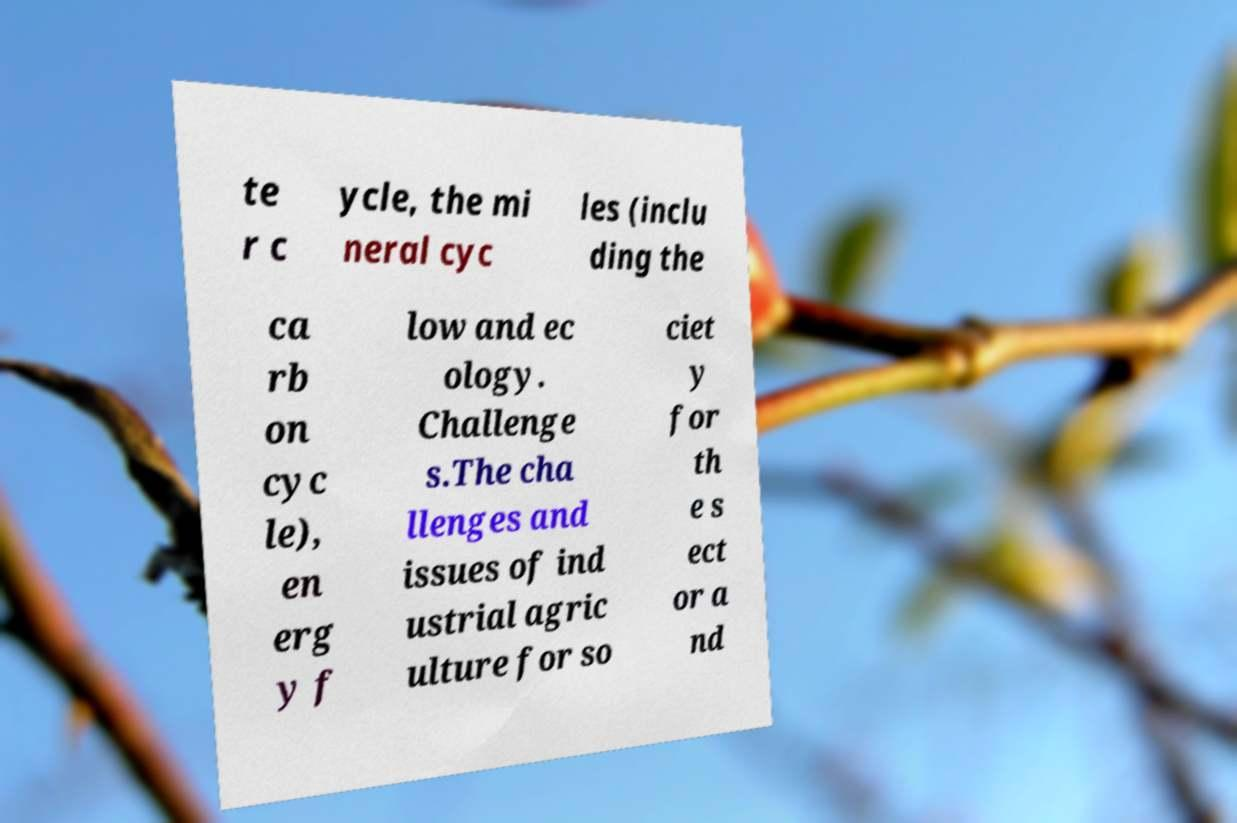What messages or text are displayed in this image? I need them in a readable, typed format. te r c ycle, the mi neral cyc les (inclu ding the ca rb on cyc le), en erg y f low and ec ology. Challenge s.The cha llenges and issues of ind ustrial agric ulture for so ciet y for th e s ect or a nd 